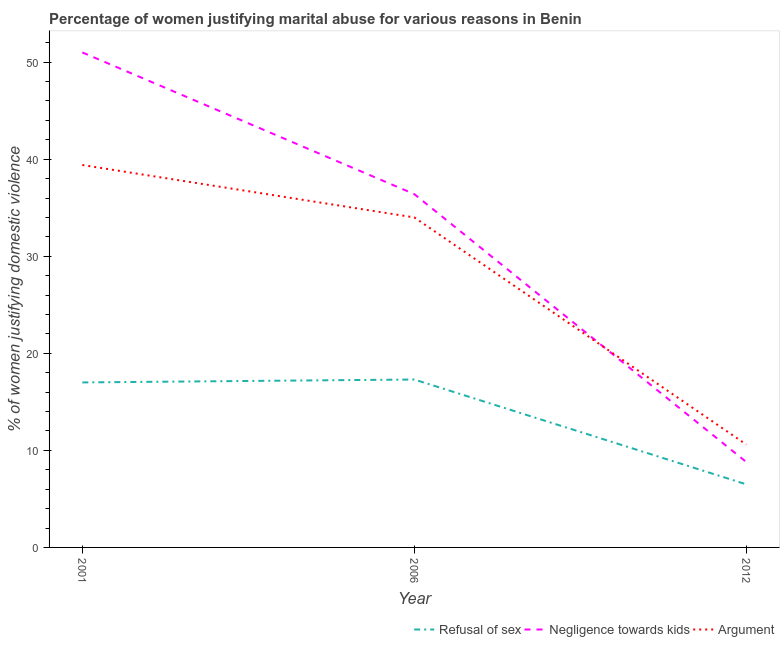How many different coloured lines are there?
Your answer should be compact. 3. What is the percentage of women justifying domestic violence due to refusal of sex in 2001?
Give a very brief answer. 17. Across all years, what is the maximum percentage of women justifying domestic violence due to arguments?
Keep it short and to the point. 39.4. What is the total percentage of women justifying domestic violence due to refusal of sex in the graph?
Provide a short and direct response. 40.8. What is the difference between the percentage of women justifying domestic violence due to refusal of sex in 2001 and that in 2012?
Your answer should be compact. 10.5. What is the difference between the percentage of women justifying domestic violence due to refusal of sex in 2006 and the percentage of women justifying domestic violence due to arguments in 2001?
Offer a terse response. -22.1. What is the average percentage of women justifying domestic violence due to refusal of sex per year?
Provide a short and direct response. 13.6. In the year 2006, what is the difference between the percentage of women justifying domestic violence due to arguments and percentage of women justifying domestic violence due to negligence towards kids?
Your response must be concise. -2.4. In how many years, is the percentage of women justifying domestic violence due to arguments greater than 50 %?
Provide a short and direct response. 0. What is the ratio of the percentage of women justifying domestic violence due to refusal of sex in 2001 to that in 2012?
Provide a succinct answer. 2.62. Is the difference between the percentage of women justifying domestic violence due to refusal of sex in 2001 and 2006 greater than the difference between the percentage of women justifying domestic violence due to arguments in 2001 and 2006?
Your response must be concise. No. What is the difference between the highest and the second highest percentage of women justifying domestic violence due to negligence towards kids?
Keep it short and to the point. 14.6. What is the difference between the highest and the lowest percentage of women justifying domestic violence due to refusal of sex?
Provide a succinct answer. 10.8. In how many years, is the percentage of women justifying domestic violence due to arguments greater than the average percentage of women justifying domestic violence due to arguments taken over all years?
Give a very brief answer. 2. Does the percentage of women justifying domestic violence due to arguments monotonically increase over the years?
Your answer should be compact. No. How many years are there in the graph?
Make the answer very short. 3. Are the values on the major ticks of Y-axis written in scientific E-notation?
Give a very brief answer. No. Does the graph contain any zero values?
Ensure brevity in your answer.  No. Where does the legend appear in the graph?
Offer a very short reply. Bottom right. What is the title of the graph?
Ensure brevity in your answer.  Percentage of women justifying marital abuse for various reasons in Benin. Does "Social Protection" appear as one of the legend labels in the graph?
Make the answer very short. No. What is the label or title of the X-axis?
Make the answer very short. Year. What is the label or title of the Y-axis?
Make the answer very short. % of women justifying domestic violence. What is the % of women justifying domestic violence in Refusal of sex in 2001?
Your answer should be compact. 17. What is the % of women justifying domestic violence in Argument in 2001?
Offer a very short reply. 39.4. What is the % of women justifying domestic violence of Refusal of sex in 2006?
Your response must be concise. 17.3. What is the % of women justifying domestic violence in Negligence towards kids in 2006?
Offer a very short reply. 36.4. Across all years, what is the maximum % of women justifying domestic violence in Argument?
Give a very brief answer. 39.4. Across all years, what is the minimum % of women justifying domestic violence in Negligence towards kids?
Your answer should be very brief. 8.8. What is the total % of women justifying domestic violence of Refusal of sex in the graph?
Offer a terse response. 40.8. What is the total % of women justifying domestic violence in Negligence towards kids in the graph?
Keep it short and to the point. 96.2. What is the difference between the % of women justifying domestic violence in Refusal of sex in 2001 and that in 2006?
Give a very brief answer. -0.3. What is the difference between the % of women justifying domestic violence in Argument in 2001 and that in 2006?
Offer a terse response. 5.4. What is the difference between the % of women justifying domestic violence in Negligence towards kids in 2001 and that in 2012?
Offer a terse response. 42.2. What is the difference between the % of women justifying domestic violence of Argument in 2001 and that in 2012?
Your answer should be compact. 28.8. What is the difference between the % of women justifying domestic violence of Refusal of sex in 2006 and that in 2012?
Your answer should be very brief. 10.8. What is the difference between the % of women justifying domestic violence of Negligence towards kids in 2006 and that in 2012?
Ensure brevity in your answer.  27.6. What is the difference between the % of women justifying domestic violence of Argument in 2006 and that in 2012?
Ensure brevity in your answer.  23.4. What is the difference between the % of women justifying domestic violence of Refusal of sex in 2001 and the % of women justifying domestic violence of Negligence towards kids in 2006?
Offer a terse response. -19.4. What is the difference between the % of women justifying domestic violence of Refusal of sex in 2001 and the % of women justifying domestic violence of Argument in 2006?
Provide a succinct answer. -17. What is the difference between the % of women justifying domestic violence of Negligence towards kids in 2001 and the % of women justifying domestic violence of Argument in 2012?
Provide a succinct answer. 40.4. What is the difference between the % of women justifying domestic violence in Negligence towards kids in 2006 and the % of women justifying domestic violence in Argument in 2012?
Provide a short and direct response. 25.8. What is the average % of women justifying domestic violence of Refusal of sex per year?
Your answer should be very brief. 13.6. What is the average % of women justifying domestic violence in Negligence towards kids per year?
Your response must be concise. 32.07. What is the average % of women justifying domestic violence in Argument per year?
Your answer should be compact. 28. In the year 2001, what is the difference between the % of women justifying domestic violence in Refusal of sex and % of women justifying domestic violence in Negligence towards kids?
Ensure brevity in your answer.  -34. In the year 2001, what is the difference between the % of women justifying domestic violence of Refusal of sex and % of women justifying domestic violence of Argument?
Your response must be concise. -22.4. In the year 2006, what is the difference between the % of women justifying domestic violence in Refusal of sex and % of women justifying domestic violence in Negligence towards kids?
Offer a terse response. -19.1. In the year 2006, what is the difference between the % of women justifying domestic violence of Refusal of sex and % of women justifying domestic violence of Argument?
Give a very brief answer. -16.7. In the year 2006, what is the difference between the % of women justifying domestic violence of Negligence towards kids and % of women justifying domestic violence of Argument?
Ensure brevity in your answer.  2.4. In the year 2012, what is the difference between the % of women justifying domestic violence of Refusal of sex and % of women justifying domestic violence of Argument?
Give a very brief answer. -4.1. What is the ratio of the % of women justifying domestic violence in Refusal of sex in 2001 to that in 2006?
Keep it short and to the point. 0.98. What is the ratio of the % of women justifying domestic violence in Negligence towards kids in 2001 to that in 2006?
Ensure brevity in your answer.  1.4. What is the ratio of the % of women justifying domestic violence in Argument in 2001 to that in 2006?
Your answer should be very brief. 1.16. What is the ratio of the % of women justifying domestic violence in Refusal of sex in 2001 to that in 2012?
Ensure brevity in your answer.  2.62. What is the ratio of the % of women justifying domestic violence in Negligence towards kids in 2001 to that in 2012?
Give a very brief answer. 5.8. What is the ratio of the % of women justifying domestic violence of Argument in 2001 to that in 2012?
Offer a very short reply. 3.72. What is the ratio of the % of women justifying domestic violence in Refusal of sex in 2006 to that in 2012?
Provide a succinct answer. 2.66. What is the ratio of the % of women justifying domestic violence of Negligence towards kids in 2006 to that in 2012?
Your answer should be compact. 4.14. What is the ratio of the % of women justifying domestic violence in Argument in 2006 to that in 2012?
Provide a succinct answer. 3.21. What is the difference between the highest and the lowest % of women justifying domestic violence in Refusal of sex?
Provide a succinct answer. 10.8. What is the difference between the highest and the lowest % of women justifying domestic violence in Negligence towards kids?
Offer a terse response. 42.2. What is the difference between the highest and the lowest % of women justifying domestic violence in Argument?
Keep it short and to the point. 28.8. 